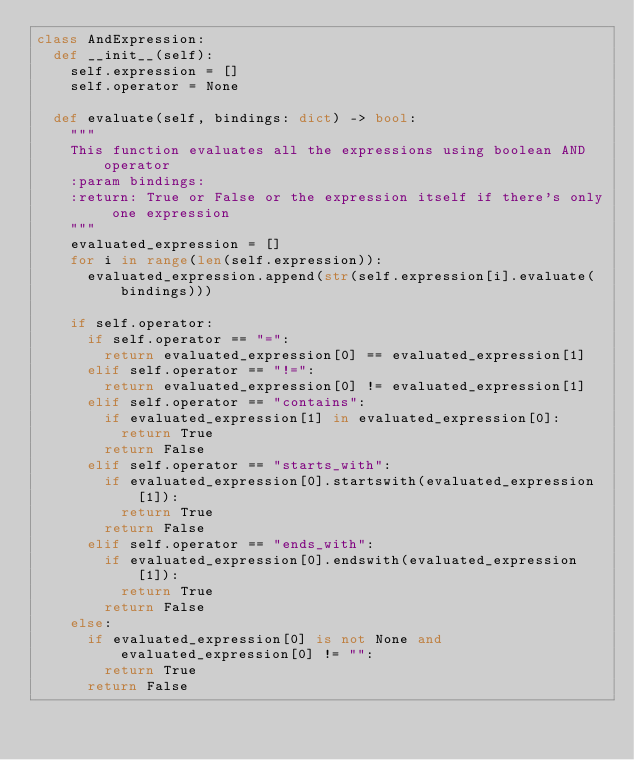Convert code to text. <code><loc_0><loc_0><loc_500><loc_500><_Python_>class AndExpression:
	def __init__(self):
		self.expression = []
		self.operator = None

	def evaluate(self, bindings: dict) -> bool:
		"""
		This function evaluates all the expressions using boolean AND operator
		:param bindings:
		:return: True or False or the expression itself if there's only one expression
		"""
		evaluated_expression = []
		for i in range(len(self.expression)):
			evaluated_expression.append(str(self.expression[i].evaluate(bindings)))

		if self.operator:
			if self.operator == "=":
				return evaluated_expression[0] == evaluated_expression[1]
			elif self.operator == "!=":
				return evaluated_expression[0] != evaluated_expression[1]
			elif self.operator == "contains":
				if evaluated_expression[1] in evaluated_expression[0]:
					return True
				return False
			elif self.operator == "starts_with":
				if evaluated_expression[0].startswith(evaluated_expression[1]):
					return True
				return False
			elif self.operator == "ends_with":
				if evaluated_expression[0].endswith(evaluated_expression[1]):
					return True
				return False
		else:
			if evaluated_expression[0] is not None and evaluated_expression[0] != "":
				return True
			return False
</code> 